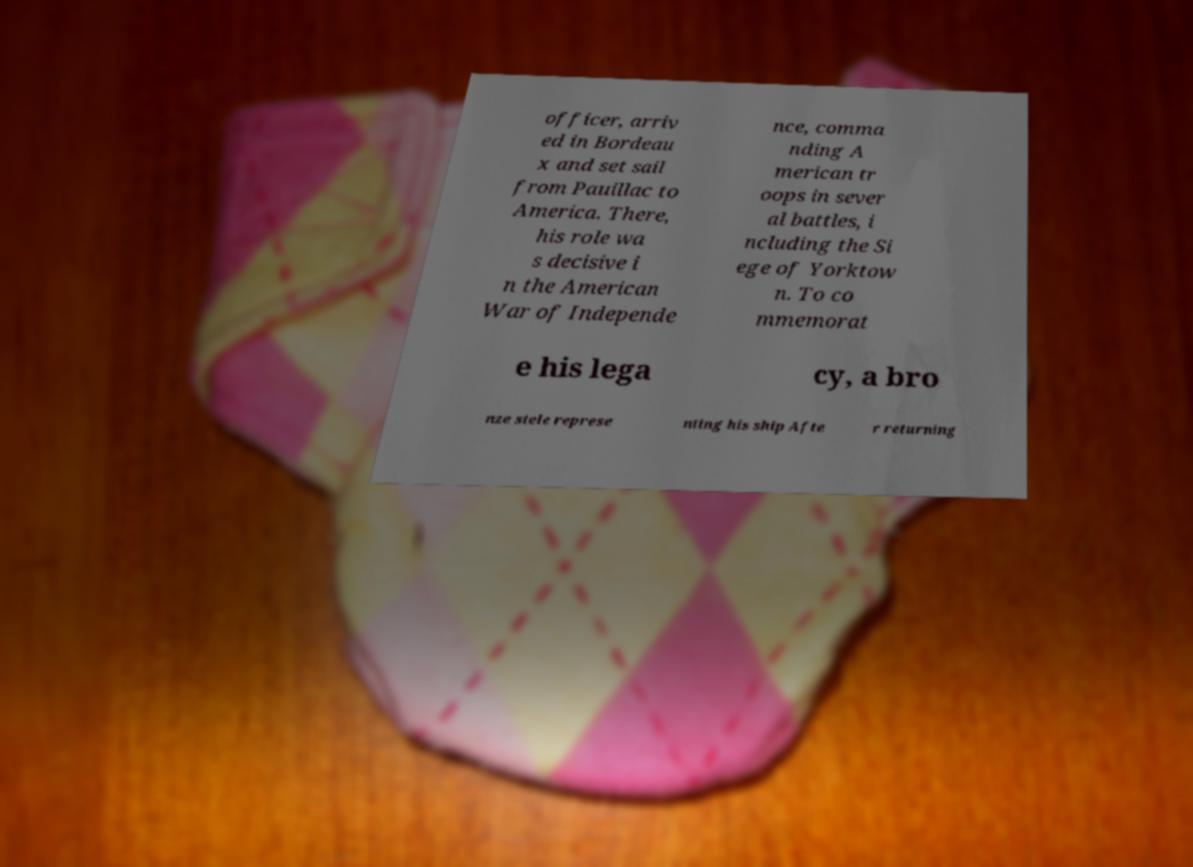I need the written content from this picture converted into text. Can you do that? officer, arriv ed in Bordeau x and set sail from Pauillac to America. There, his role wa s decisive i n the American War of Independe nce, comma nding A merican tr oops in sever al battles, i ncluding the Si ege of Yorktow n. To co mmemorat e his lega cy, a bro nze stele represe nting his ship Afte r returning 